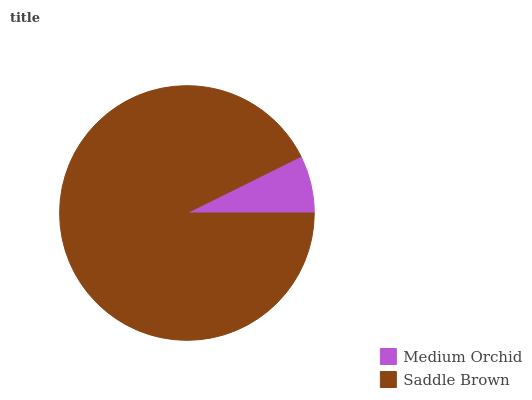Is Medium Orchid the minimum?
Answer yes or no. Yes. Is Saddle Brown the maximum?
Answer yes or no. Yes. Is Saddle Brown the minimum?
Answer yes or no. No. Is Saddle Brown greater than Medium Orchid?
Answer yes or no. Yes. Is Medium Orchid less than Saddle Brown?
Answer yes or no. Yes. Is Medium Orchid greater than Saddle Brown?
Answer yes or no. No. Is Saddle Brown less than Medium Orchid?
Answer yes or no. No. Is Saddle Brown the high median?
Answer yes or no. Yes. Is Medium Orchid the low median?
Answer yes or no. Yes. Is Medium Orchid the high median?
Answer yes or no. No. Is Saddle Brown the low median?
Answer yes or no. No. 